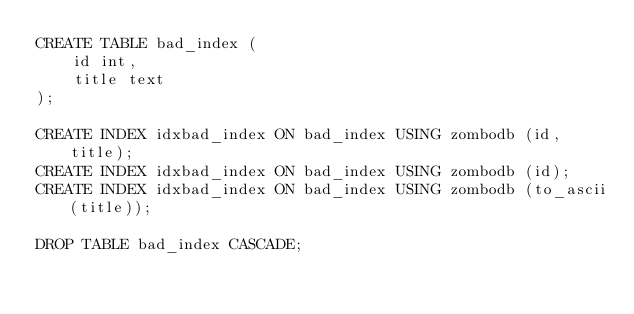<code> <loc_0><loc_0><loc_500><loc_500><_SQL_>CREATE TABLE bad_index (
    id int,
    title text
);

CREATE INDEX idxbad_index ON bad_index USING zombodb (id, title);
CREATE INDEX idxbad_index ON bad_index USING zombodb (id);
CREATE INDEX idxbad_index ON bad_index USING zombodb (to_ascii(title));

DROP TABLE bad_index CASCADE;
</code> 